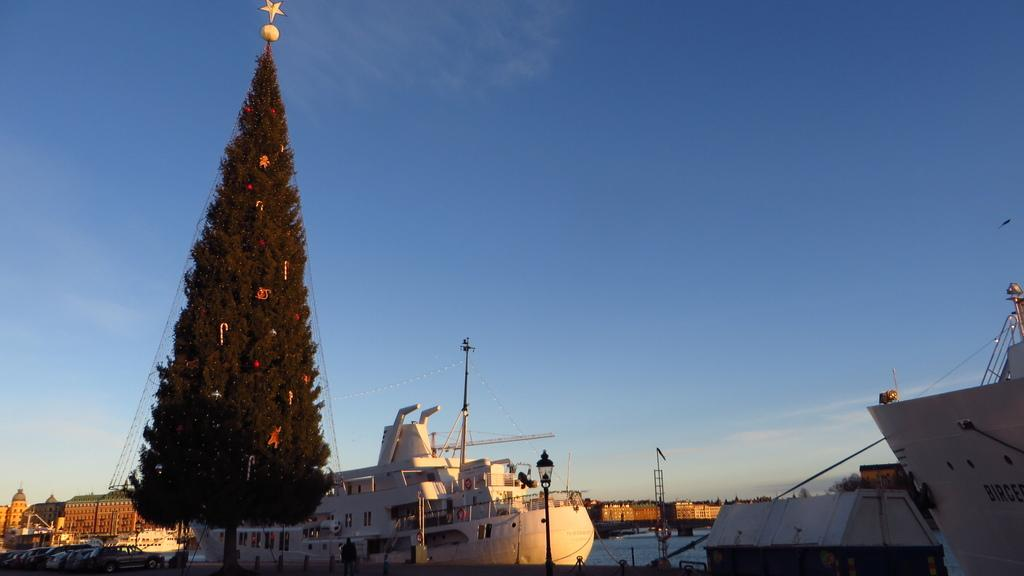What is the main subject of the image? The main subject of the image is ships. Can you describe any other objects or features on the left side of the image? There is a tree on the left side of the image. What can be seen in the background of the image? There are buildings and clouds in the sky in the background of the image. What type of rice is being served in the image? There is no rice present in the image; it features ships, a tree, buildings, and clouds in the sky. How many screws can be seen holding the ship together in the image? There are no screws visible in the image; it is a photograph or illustration, not a detailed technical drawing. 